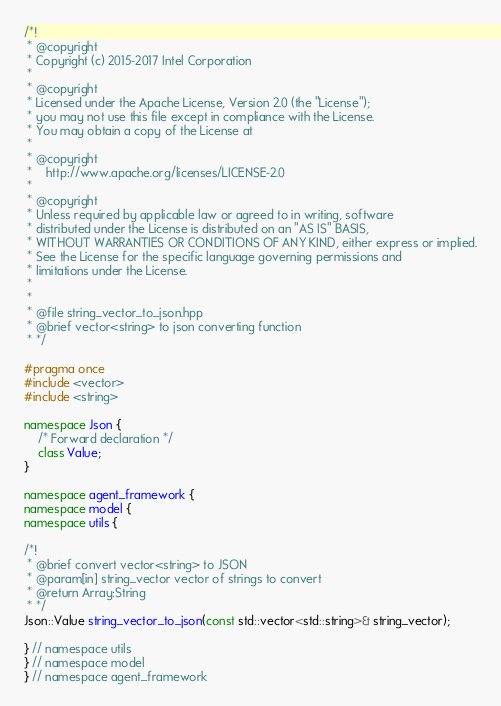Convert code to text. <code><loc_0><loc_0><loc_500><loc_500><_C++_>/*!
 * @copyright
 * Copyright (c) 2015-2017 Intel Corporation
 *
 * @copyright
 * Licensed under the Apache License, Version 2.0 (the "License");
 * you may not use this file except in compliance with the License.
 * You may obtain a copy of the License at
 *
 * @copyright
 *    http://www.apache.org/licenses/LICENSE-2.0
 *
 * @copyright
 * Unless required by applicable law or agreed to in writing, software
 * distributed under the License is distributed on an "AS IS" BASIS,
 * WITHOUT WARRANTIES OR CONDITIONS OF ANY KIND, either express or implied.
 * See the License for the specific language governing permissions and
 * limitations under the License.
 *
 *
 * @file string_vector_to_json.hpp
 * @brief vector<string> to json converting function
 * */

#pragma once
#include <vector>
#include <string>

namespace Json {
    /* Forward declaration */
    class Value;
}

namespace agent_framework {
namespace model {
namespace utils {

/*!
 * @brief convert vector<string> to JSON
 * @param[in] string_vector vector of strings to convert
 * @return Array:String
 * */
Json::Value string_vector_to_json(const std::vector<std::string>& string_vector);

} // namespace utils
} // namespace model
} // namespace agent_framework

</code> 